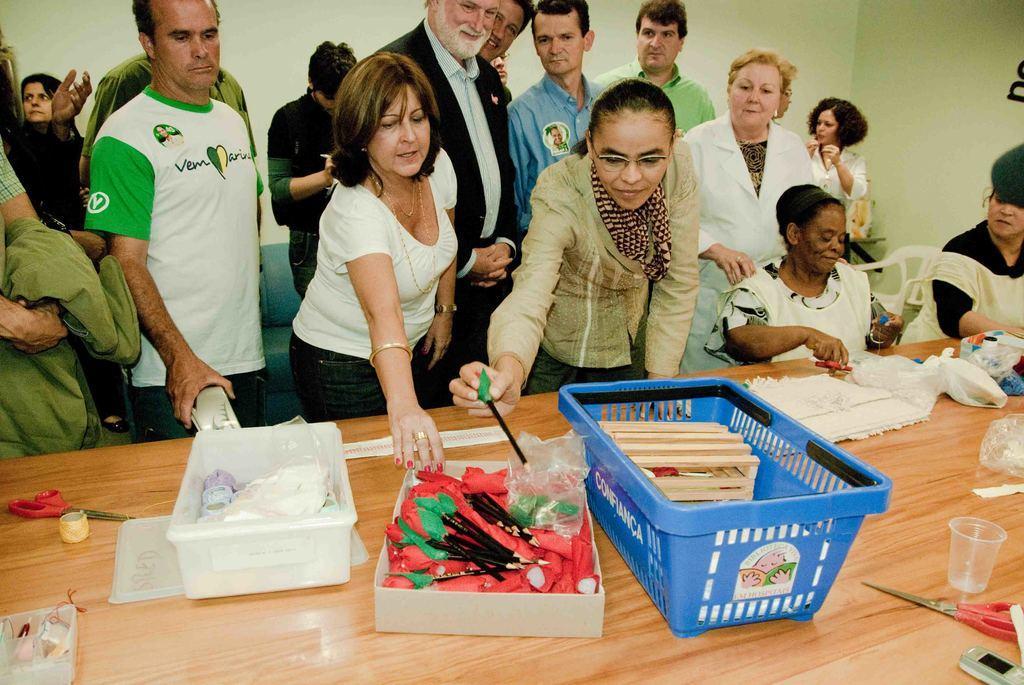Can you describe this image briefly? In this image on the table there is a basket, pens , scissors, cups and few other things are there. In the background there are many people. 